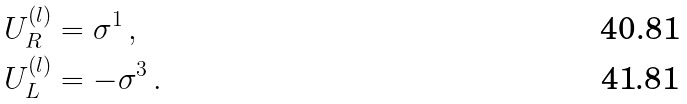<formula> <loc_0><loc_0><loc_500><loc_500>U _ { R } ^ { ( l ) } & = \sigma ^ { 1 } \, , \\ U _ { L } ^ { ( l ) } & = - \sigma ^ { 3 } \, .</formula> 